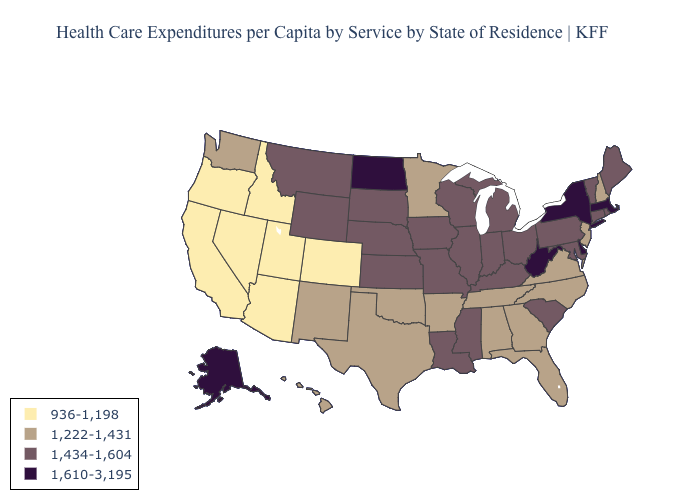Which states have the lowest value in the USA?
Be succinct. Arizona, California, Colorado, Idaho, Nevada, Oregon, Utah. Which states have the lowest value in the USA?
Answer briefly. Arizona, California, Colorado, Idaho, Nevada, Oregon, Utah. What is the value of North Dakota?
Concise answer only. 1,610-3,195. Does Colorado have the lowest value in the USA?
Give a very brief answer. Yes. What is the highest value in the West ?
Quick response, please. 1,610-3,195. Does Michigan have the lowest value in the USA?
Concise answer only. No. What is the highest value in the Northeast ?
Concise answer only. 1,610-3,195. Which states have the highest value in the USA?
Quick response, please. Alaska, Delaware, Massachusetts, New York, North Dakota, West Virginia. Name the states that have a value in the range 1,434-1,604?
Quick response, please. Connecticut, Illinois, Indiana, Iowa, Kansas, Kentucky, Louisiana, Maine, Maryland, Michigan, Mississippi, Missouri, Montana, Nebraska, Ohio, Pennsylvania, Rhode Island, South Carolina, South Dakota, Vermont, Wisconsin, Wyoming. What is the highest value in states that border Utah?
Answer briefly. 1,434-1,604. What is the value of Hawaii?
Answer briefly. 1,222-1,431. Which states have the highest value in the USA?
Write a very short answer. Alaska, Delaware, Massachusetts, New York, North Dakota, West Virginia. Name the states that have a value in the range 1,222-1,431?
Quick response, please. Alabama, Arkansas, Florida, Georgia, Hawaii, Minnesota, New Hampshire, New Jersey, New Mexico, North Carolina, Oklahoma, Tennessee, Texas, Virginia, Washington. Does the first symbol in the legend represent the smallest category?
Keep it brief. Yes. Name the states that have a value in the range 1,434-1,604?
Answer briefly. Connecticut, Illinois, Indiana, Iowa, Kansas, Kentucky, Louisiana, Maine, Maryland, Michigan, Mississippi, Missouri, Montana, Nebraska, Ohio, Pennsylvania, Rhode Island, South Carolina, South Dakota, Vermont, Wisconsin, Wyoming. 